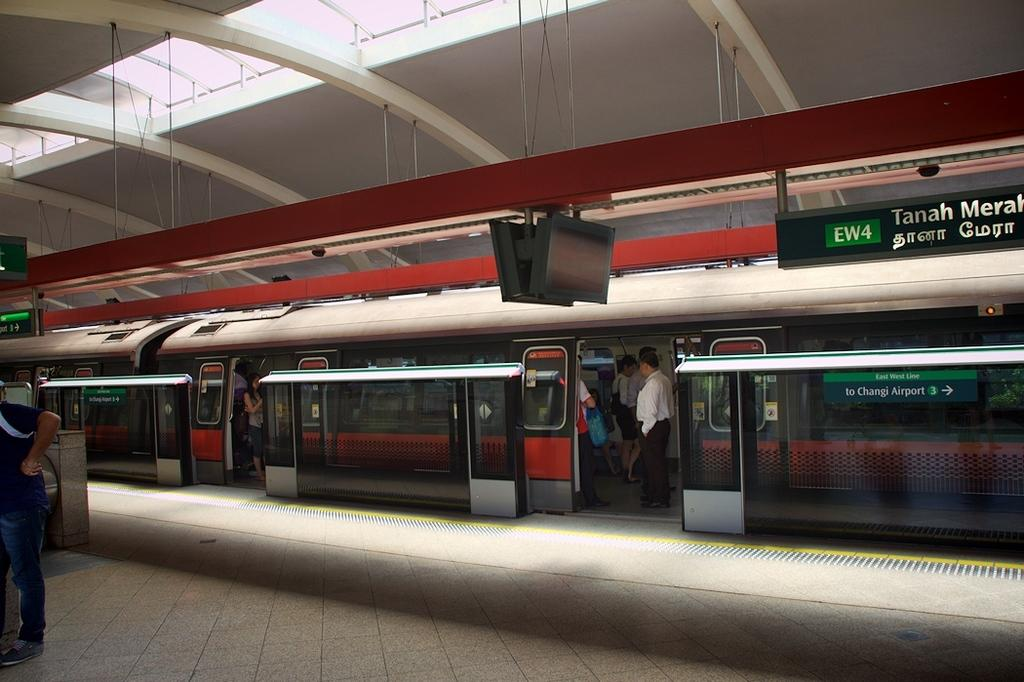What is the main subject of the image? The main subject of the image is a train. What else can be seen in the image besides the train? There is a platform, a display board, and a man standing in the image. What might the display board be used for? The display board in the image might be used to provide information about train schedules or routes. Can you describe the people in the image? There is a man standing in the image, and there are people inside the train. How fast is the snail moving on the train in the image? There is no snail present in the image, so it is not possible to determine its speed or movement. 